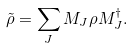<formula> <loc_0><loc_0><loc_500><loc_500>\tilde { \rho } = \sum _ { J } M _ { J } \rho M _ { J } ^ { \dagger } .</formula> 